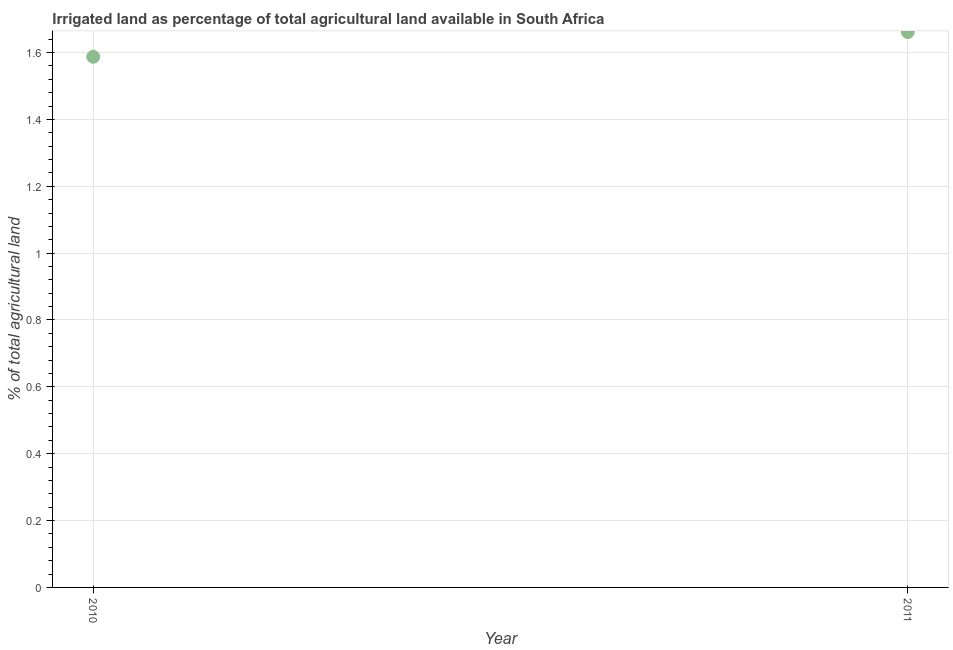What is the percentage of agricultural irrigated land in 2010?
Offer a terse response. 1.59. Across all years, what is the maximum percentage of agricultural irrigated land?
Offer a very short reply. 1.66. Across all years, what is the minimum percentage of agricultural irrigated land?
Offer a very short reply. 1.59. What is the sum of the percentage of agricultural irrigated land?
Your answer should be compact. 3.25. What is the difference between the percentage of agricultural irrigated land in 2010 and 2011?
Provide a succinct answer. -0.07. What is the average percentage of agricultural irrigated land per year?
Provide a short and direct response. 1.62. What is the median percentage of agricultural irrigated land?
Give a very brief answer. 1.62. What is the ratio of the percentage of agricultural irrigated land in 2010 to that in 2011?
Ensure brevity in your answer.  0.96. Does the percentage of agricultural irrigated land monotonically increase over the years?
Give a very brief answer. Yes. What is the difference between two consecutive major ticks on the Y-axis?
Give a very brief answer. 0.2. What is the title of the graph?
Your answer should be very brief. Irrigated land as percentage of total agricultural land available in South Africa. What is the label or title of the Y-axis?
Provide a succinct answer. % of total agricultural land. What is the % of total agricultural land in 2010?
Offer a very short reply. 1.59. What is the % of total agricultural land in 2011?
Provide a short and direct response. 1.66. What is the difference between the % of total agricultural land in 2010 and 2011?
Give a very brief answer. -0.07. What is the ratio of the % of total agricultural land in 2010 to that in 2011?
Provide a short and direct response. 0.96. 